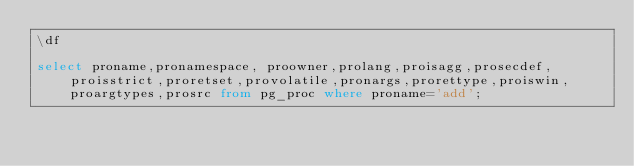Convert code to text. <code><loc_0><loc_0><loc_500><loc_500><_SQL_>\df

select proname,pronamespace, proowner,prolang,proisagg,prosecdef,proisstrict,proretset,provolatile,pronargs,prorettype,proiswin,proargtypes,prosrc from pg_proc where proname='add';
</code> 